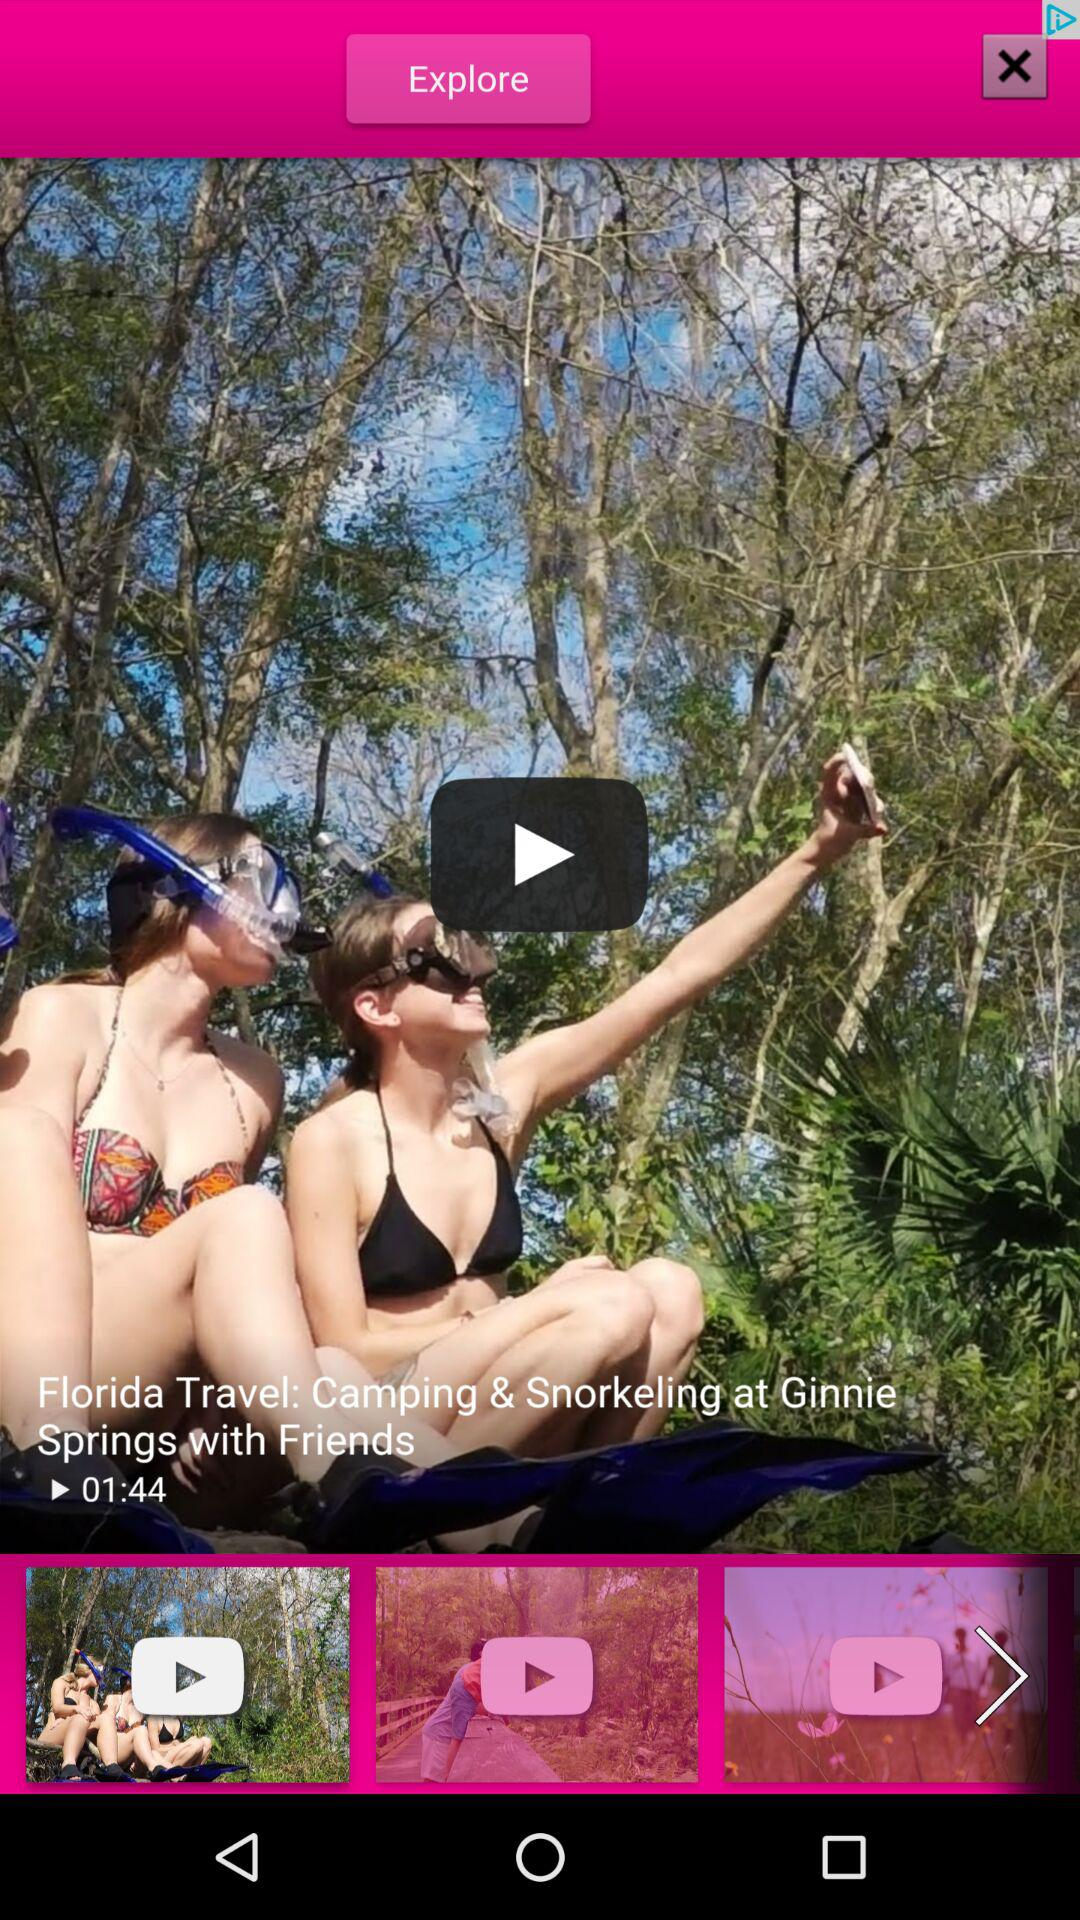What is the time duration of the video "Florida Travel: Camping & Snorkeling at Ginnie Springs with Friends"? The time duration of the video is 1 minute 44 seconds. 